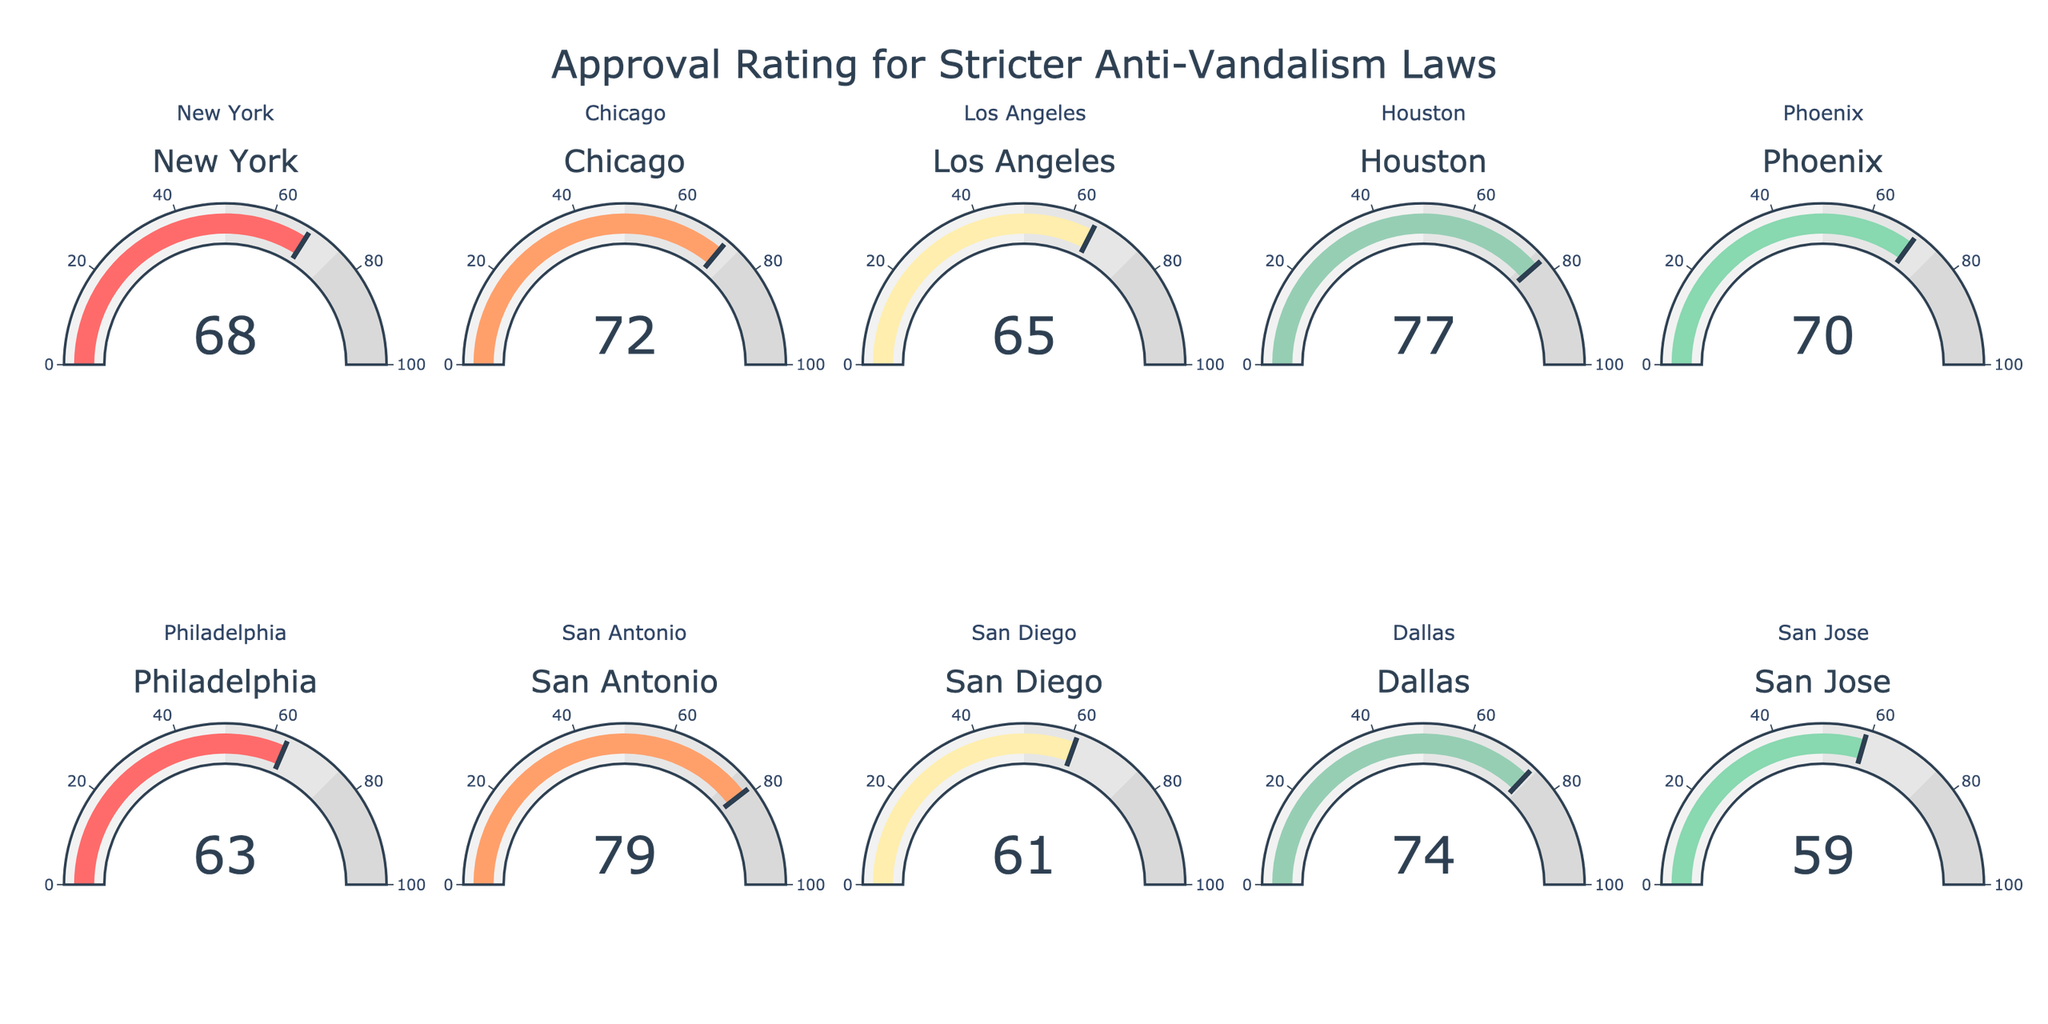What's the approval rating for New York? Look at the gauge labeled "New York" and read the number displayed on the gauge.
Answer: 68 Which city has the highest approval rating for stricter anti-vandalism laws? Compare the numbers displayed on each city's gauge and identify the highest number.
Answer: San Antonio What is the average approval rating across all cities? Sum up the approval ratings of all cities and divide by the number of cities: (68 + 72 + 65 + 77 + 70 + 63 + 79 + 61 + 74 + 59) / 10.
Answer: 68.8 What is the range of approval ratings? Identify the highest and lowest ratings: highest is 79 (San Antonio), lowest is 59 (San Jose). Calculate the range: 79 - 59.
Answer: 20 How many cities have an approval rating above 70? Count the number of gauges displaying a value greater than 70: Chicago (72), Houston (77), San Antonio (79), Dallas (74).
Answer: 4 Which city's approval rating is closest to the average approval rating? Calculate the absolute difference between each city's approval rating and the average (68.8). The smallest difference is closest: New York (68), Chicago (72), Los Angeles (65), Houston (77), Phoenix (70), Philadelphia (63), San Antonio (79), San Diego (61), Dallas (74), San Jose (59)
Answer: Phoenix What is the difference in approval ratings between the highest-rated and lowest-rated cities? Identify the highest and lowest ratings: San Antonio (79) and San Jose (59). Subtract the smallest from the largest: 79 - 59.
Answer: 20 Between Houston and Dallas, which city has a higher approval rating? Compare the numbers displayed on Houston's and Dallas's gauges: Houston (77), Dallas (74).
Answer: Houston Which cities have an approval rating below 65? Identify gauges with ratings below 65: Philadelphia (63), San Diego (61), San Jose (59).
Answer: Philadelphia, San Diego, San Jose If the approval rating of San Jose were to increase by 10, what would the new value be? Add 10 to San Jose's current rating: 59 + 10.
Answer: 69 